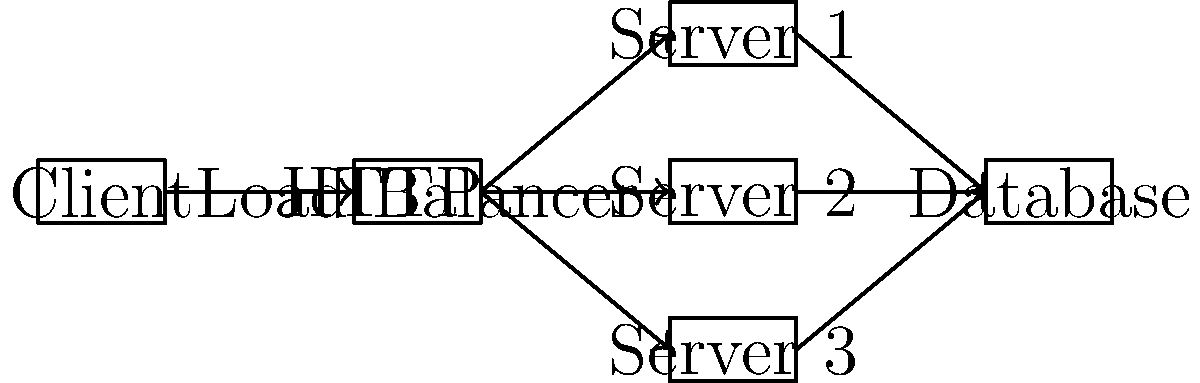In the given client-server architecture diagram, which component is crucial for ensuring high availability and distributing network traffic efficiently across multiple servers? To answer this question, let's analyze the components and their roles in the architecture:

1. Client: This is the end-user application that initiates requests to the server.

2. Load Balancer: This component sits between the client and the servers. It receives incoming requests from clients and distributes them across multiple server instances.

3. Servers (1, 2, 3): These are identical server instances that process client requests and interact with the database.

4. Database: This is the central data storage component that all servers interact with.

The key component for ensuring high availability and efficient distribution of network traffic is the Load Balancer. Here's why:

1. High Availability: By distributing requests across multiple servers, the Load Balancer ensures that if one server fails, others can still handle incoming requests. This prevents a single point of failure and increases the overall system availability.

2. Efficient Traffic Distribution: The Load Balancer can use various algorithms (e.g., round-robin, least connections, etc.) to distribute traffic evenly across servers. This prevents any single server from becoming overloaded while others are underutilized.

3. Scalability: As the system needs to handle more traffic, additional server instances can be added behind the Load Balancer without changing the client-side configuration.

4. Performance Optimization: The Load Balancer can direct requests to the most appropriate server based on factors like server health, current load, or geographic location, improving overall system performance.

In the context of network programming, especially for a senior Delphi programmer with experience in this field, understanding the role and implementation of a Load Balancer is crucial for designing scalable and resilient client-server architectures.
Answer: Load Balancer 